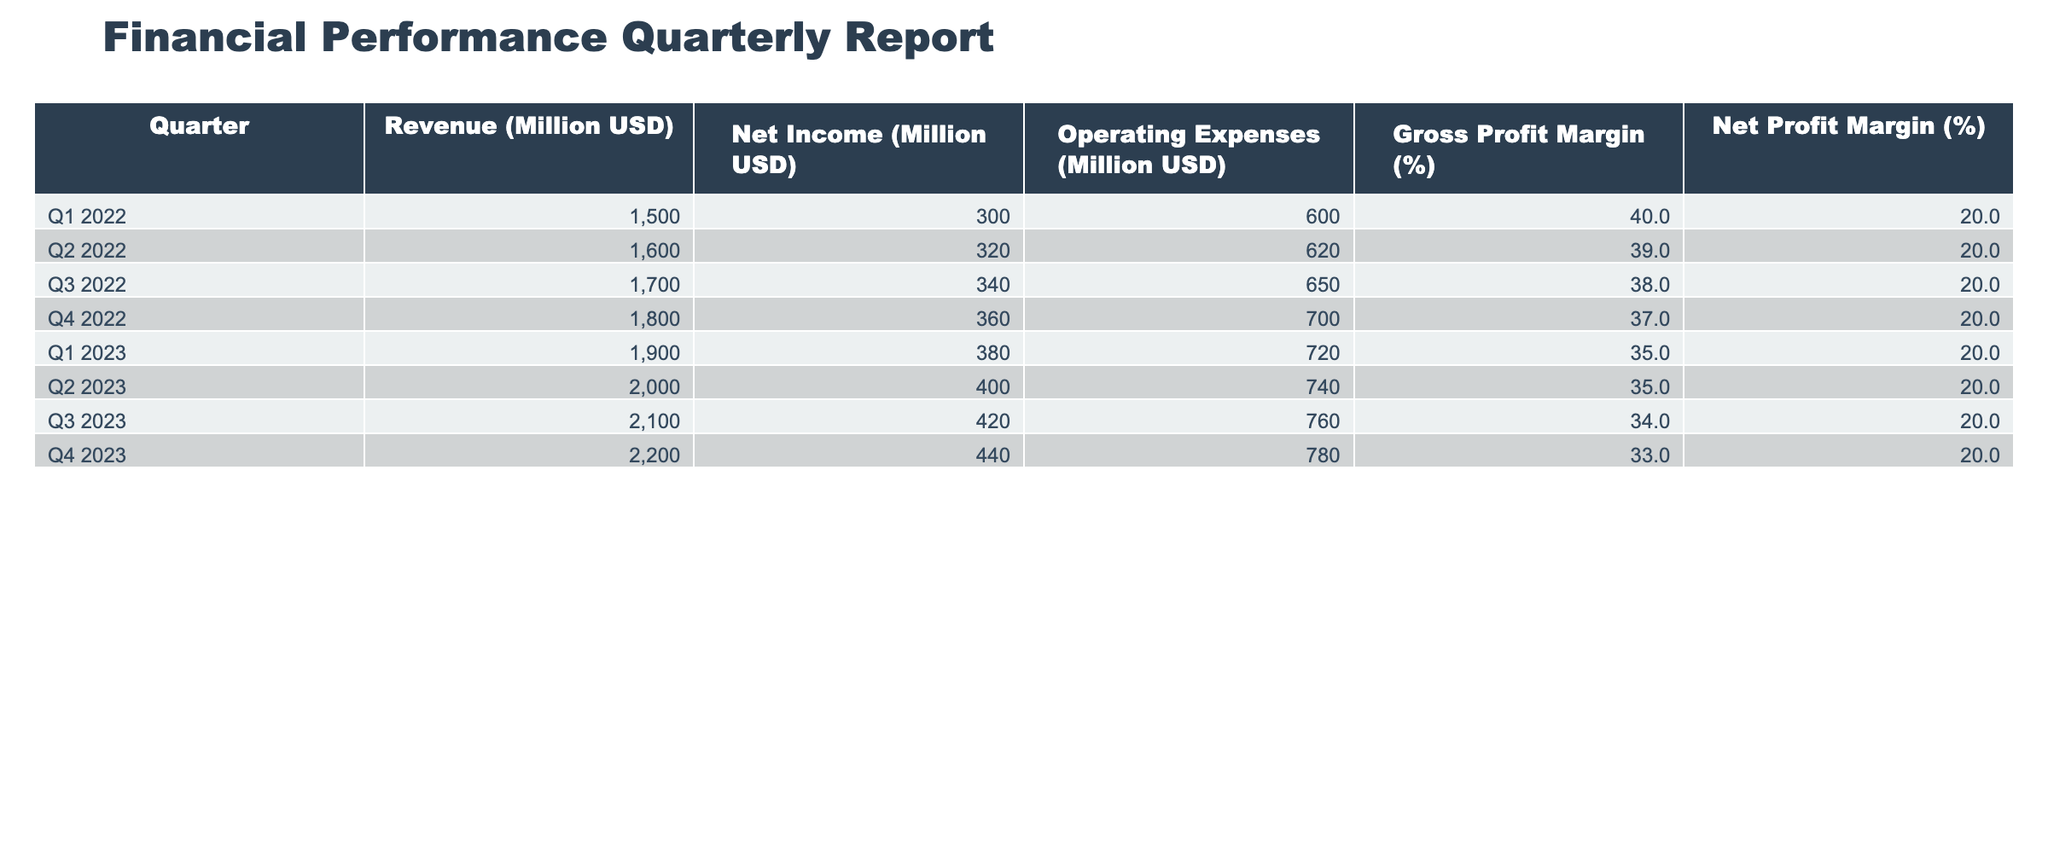What was the revenue in Q2 2023? Referring directly to the table, the revenue in Q2 2023 is found in the corresponding row under the Revenue column, which states 2000 million USD.
Answer: 2000 million USD Which quarter had the highest net income? By scanning the Net Income column, Q4 2023 shows the highest value at 440 million USD compared to other quarters.
Answer: Q4 2023 What is the average gross profit margin across all quarters? We sum the values in the Gross Profit Margin column: (40 + 39 + 38 + 37 + 35 + 35 + 34 + 33) = 311. Dividing by the number of quarters (8) yields an average of 311/8 = 38.875, which rounds to 38.9.
Answer: 38.9 Did any quarter have a net profit margin above 25%? Checking the Net Profit Margin column, all values are stagnant at 20%, which confirms that no quarter surpassed 25% net profit margin.
Answer: No In which quarter was the operating expense the lowest and what was the value? Reviewing the Operating Expenses column, Q1 2022 shows the lowest operating expense at 600 million USD, as all subsequent quarters report higher figures.
Answer: Q1 2022, 600 million USD What is the difference in revenue between Q1 2022 and Q4 2023? The revenue for Q1 2022 is 1500 million USD and for Q4 2023 is 2200 million USD. The difference is calculated as 2200 - 1500 = 700 million USD.
Answer: 700 million USD Which quarter experienced the highest operating expenses? Examining the Operating Expenses column, Q4 2023 has the highest operating expenses of 780 million USD, as it exceeds the other quarters.
Answer: Q4 2023 If we look at the revenue growth from Q2 2022 to Q4 2023, what percentage increase occurred? The revenue for Q2 2022 is 1600 million USD and for Q4 2023 is 2200 million USD. First, find the growth amount: 2200 - 1600 = 600 million USD. Then, calculate the percentage increase: (600/1600) * 100 = 37.5%.
Answer: 37.5% 